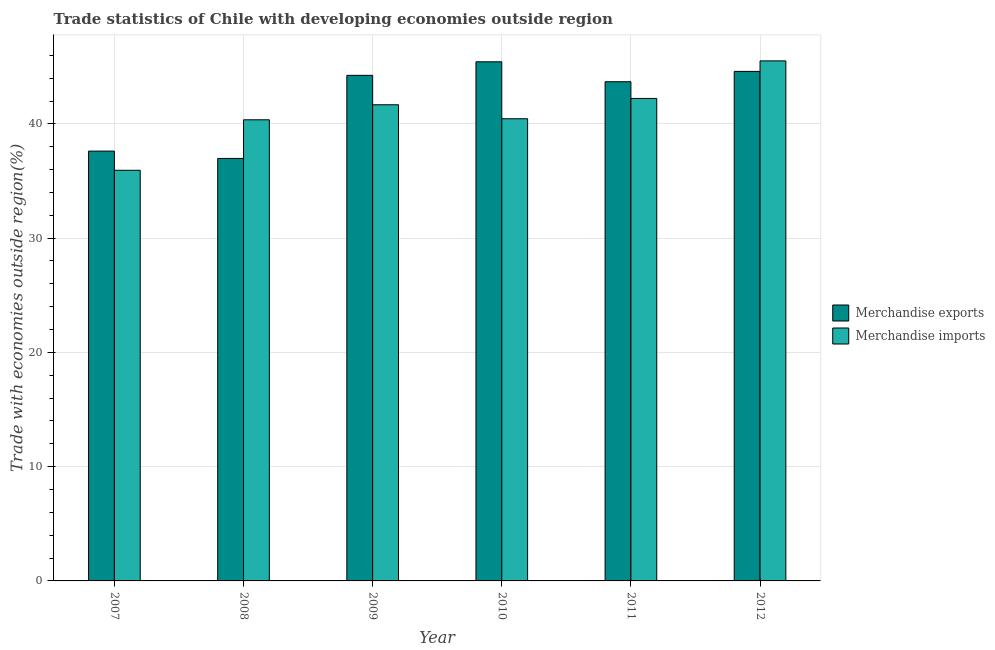Are the number of bars on each tick of the X-axis equal?
Provide a succinct answer. Yes. What is the label of the 1st group of bars from the left?
Ensure brevity in your answer.  2007. In how many cases, is the number of bars for a given year not equal to the number of legend labels?
Provide a succinct answer. 0. What is the merchandise exports in 2012?
Your answer should be compact. 44.59. Across all years, what is the maximum merchandise imports?
Your response must be concise. 45.51. Across all years, what is the minimum merchandise exports?
Keep it short and to the point. 36.98. In which year was the merchandise imports maximum?
Your response must be concise. 2012. In which year was the merchandise imports minimum?
Ensure brevity in your answer.  2007. What is the total merchandise exports in the graph?
Give a very brief answer. 252.56. What is the difference between the merchandise imports in 2007 and that in 2008?
Your response must be concise. -4.42. What is the difference between the merchandise exports in 2012 and the merchandise imports in 2009?
Your response must be concise. 0.35. What is the average merchandise imports per year?
Offer a very short reply. 41.03. What is the ratio of the merchandise imports in 2007 to that in 2008?
Provide a short and direct response. 0.89. What is the difference between the highest and the second highest merchandise imports?
Your response must be concise. 3.29. What is the difference between the highest and the lowest merchandise imports?
Offer a very short reply. 9.58. In how many years, is the merchandise imports greater than the average merchandise imports taken over all years?
Provide a short and direct response. 3. What does the 2nd bar from the left in 2011 represents?
Your answer should be compact. Merchandise imports. How many bars are there?
Your response must be concise. 12. What is the difference between two consecutive major ticks on the Y-axis?
Offer a very short reply. 10. Does the graph contain any zero values?
Keep it short and to the point. No. Where does the legend appear in the graph?
Offer a terse response. Center right. What is the title of the graph?
Offer a very short reply. Trade statistics of Chile with developing economies outside region. What is the label or title of the X-axis?
Your response must be concise. Year. What is the label or title of the Y-axis?
Give a very brief answer. Trade with economies outside region(%). What is the Trade with economies outside region(%) of Merchandise exports in 2007?
Ensure brevity in your answer.  37.62. What is the Trade with economies outside region(%) in Merchandise imports in 2007?
Offer a very short reply. 35.94. What is the Trade with economies outside region(%) of Merchandise exports in 2008?
Provide a short and direct response. 36.98. What is the Trade with economies outside region(%) in Merchandise imports in 2008?
Provide a short and direct response. 40.36. What is the Trade with economies outside region(%) in Merchandise exports in 2009?
Make the answer very short. 44.25. What is the Trade with economies outside region(%) of Merchandise imports in 2009?
Ensure brevity in your answer.  41.67. What is the Trade with economies outside region(%) of Merchandise exports in 2010?
Provide a short and direct response. 45.44. What is the Trade with economies outside region(%) in Merchandise imports in 2010?
Give a very brief answer. 40.45. What is the Trade with economies outside region(%) in Merchandise exports in 2011?
Your response must be concise. 43.69. What is the Trade with economies outside region(%) of Merchandise imports in 2011?
Your response must be concise. 42.23. What is the Trade with economies outside region(%) in Merchandise exports in 2012?
Provide a succinct answer. 44.59. What is the Trade with economies outside region(%) in Merchandise imports in 2012?
Give a very brief answer. 45.51. Across all years, what is the maximum Trade with economies outside region(%) of Merchandise exports?
Offer a terse response. 45.44. Across all years, what is the maximum Trade with economies outside region(%) of Merchandise imports?
Offer a terse response. 45.51. Across all years, what is the minimum Trade with economies outside region(%) of Merchandise exports?
Keep it short and to the point. 36.98. Across all years, what is the minimum Trade with economies outside region(%) in Merchandise imports?
Ensure brevity in your answer.  35.94. What is the total Trade with economies outside region(%) in Merchandise exports in the graph?
Offer a terse response. 252.56. What is the total Trade with economies outside region(%) in Merchandise imports in the graph?
Your answer should be compact. 246.17. What is the difference between the Trade with economies outside region(%) of Merchandise exports in 2007 and that in 2008?
Provide a short and direct response. 0.64. What is the difference between the Trade with economies outside region(%) of Merchandise imports in 2007 and that in 2008?
Offer a terse response. -4.42. What is the difference between the Trade with economies outside region(%) of Merchandise exports in 2007 and that in 2009?
Offer a terse response. -6.63. What is the difference between the Trade with economies outside region(%) in Merchandise imports in 2007 and that in 2009?
Ensure brevity in your answer.  -5.73. What is the difference between the Trade with economies outside region(%) of Merchandise exports in 2007 and that in 2010?
Offer a very short reply. -7.82. What is the difference between the Trade with economies outside region(%) in Merchandise imports in 2007 and that in 2010?
Offer a very short reply. -4.51. What is the difference between the Trade with economies outside region(%) of Merchandise exports in 2007 and that in 2011?
Your answer should be compact. -6.07. What is the difference between the Trade with economies outside region(%) of Merchandise imports in 2007 and that in 2011?
Give a very brief answer. -6.29. What is the difference between the Trade with economies outside region(%) of Merchandise exports in 2007 and that in 2012?
Provide a short and direct response. -6.98. What is the difference between the Trade with economies outside region(%) in Merchandise imports in 2007 and that in 2012?
Give a very brief answer. -9.58. What is the difference between the Trade with economies outside region(%) in Merchandise exports in 2008 and that in 2009?
Ensure brevity in your answer.  -7.27. What is the difference between the Trade with economies outside region(%) of Merchandise imports in 2008 and that in 2009?
Keep it short and to the point. -1.32. What is the difference between the Trade with economies outside region(%) in Merchandise exports in 2008 and that in 2010?
Offer a very short reply. -8.46. What is the difference between the Trade with economies outside region(%) in Merchandise imports in 2008 and that in 2010?
Your response must be concise. -0.09. What is the difference between the Trade with economies outside region(%) of Merchandise exports in 2008 and that in 2011?
Ensure brevity in your answer.  -6.71. What is the difference between the Trade with economies outside region(%) of Merchandise imports in 2008 and that in 2011?
Provide a succinct answer. -1.87. What is the difference between the Trade with economies outside region(%) in Merchandise exports in 2008 and that in 2012?
Provide a short and direct response. -7.62. What is the difference between the Trade with economies outside region(%) in Merchandise imports in 2008 and that in 2012?
Give a very brief answer. -5.16. What is the difference between the Trade with economies outside region(%) in Merchandise exports in 2009 and that in 2010?
Keep it short and to the point. -1.19. What is the difference between the Trade with economies outside region(%) in Merchandise imports in 2009 and that in 2010?
Keep it short and to the point. 1.22. What is the difference between the Trade with economies outside region(%) of Merchandise exports in 2009 and that in 2011?
Your answer should be very brief. 0.56. What is the difference between the Trade with economies outside region(%) in Merchandise imports in 2009 and that in 2011?
Provide a short and direct response. -0.56. What is the difference between the Trade with economies outside region(%) of Merchandise exports in 2009 and that in 2012?
Your answer should be very brief. -0.35. What is the difference between the Trade with economies outside region(%) in Merchandise imports in 2009 and that in 2012?
Provide a short and direct response. -3.84. What is the difference between the Trade with economies outside region(%) in Merchandise exports in 2010 and that in 2011?
Provide a short and direct response. 1.75. What is the difference between the Trade with economies outside region(%) in Merchandise imports in 2010 and that in 2011?
Give a very brief answer. -1.78. What is the difference between the Trade with economies outside region(%) in Merchandise exports in 2010 and that in 2012?
Your response must be concise. 0.84. What is the difference between the Trade with economies outside region(%) of Merchandise imports in 2010 and that in 2012?
Offer a terse response. -5.06. What is the difference between the Trade with economies outside region(%) in Merchandise exports in 2011 and that in 2012?
Your response must be concise. -0.9. What is the difference between the Trade with economies outside region(%) of Merchandise imports in 2011 and that in 2012?
Ensure brevity in your answer.  -3.29. What is the difference between the Trade with economies outside region(%) in Merchandise exports in 2007 and the Trade with economies outside region(%) in Merchandise imports in 2008?
Ensure brevity in your answer.  -2.74. What is the difference between the Trade with economies outside region(%) in Merchandise exports in 2007 and the Trade with economies outside region(%) in Merchandise imports in 2009?
Offer a very short reply. -4.06. What is the difference between the Trade with economies outside region(%) in Merchandise exports in 2007 and the Trade with economies outside region(%) in Merchandise imports in 2010?
Ensure brevity in your answer.  -2.83. What is the difference between the Trade with economies outside region(%) in Merchandise exports in 2007 and the Trade with economies outside region(%) in Merchandise imports in 2011?
Your answer should be compact. -4.61. What is the difference between the Trade with economies outside region(%) in Merchandise exports in 2007 and the Trade with economies outside region(%) in Merchandise imports in 2012?
Keep it short and to the point. -7.9. What is the difference between the Trade with economies outside region(%) of Merchandise exports in 2008 and the Trade with economies outside region(%) of Merchandise imports in 2009?
Ensure brevity in your answer.  -4.7. What is the difference between the Trade with economies outside region(%) of Merchandise exports in 2008 and the Trade with economies outside region(%) of Merchandise imports in 2010?
Make the answer very short. -3.47. What is the difference between the Trade with economies outside region(%) of Merchandise exports in 2008 and the Trade with economies outside region(%) of Merchandise imports in 2011?
Provide a short and direct response. -5.25. What is the difference between the Trade with economies outside region(%) in Merchandise exports in 2008 and the Trade with economies outside region(%) in Merchandise imports in 2012?
Provide a succinct answer. -8.54. What is the difference between the Trade with economies outside region(%) of Merchandise exports in 2009 and the Trade with economies outside region(%) of Merchandise imports in 2010?
Your answer should be very brief. 3.8. What is the difference between the Trade with economies outside region(%) of Merchandise exports in 2009 and the Trade with economies outside region(%) of Merchandise imports in 2011?
Make the answer very short. 2.02. What is the difference between the Trade with economies outside region(%) of Merchandise exports in 2009 and the Trade with economies outside region(%) of Merchandise imports in 2012?
Give a very brief answer. -1.27. What is the difference between the Trade with economies outside region(%) in Merchandise exports in 2010 and the Trade with economies outside region(%) in Merchandise imports in 2011?
Offer a terse response. 3.21. What is the difference between the Trade with economies outside region(%) in Merchandise exports in 2010 and the Trade with economies outside region(%) in Merchandise imports in 2012?
Offer a very short reply. -0.08. What is the difference between the Trade with economies outside region(%) of Merchandise exports in 2011 and the Trade with economies outside region(%) of Merchandise imports in 2012?
Give a very brief answer. -1.83. What is the average Trade with economies outside region(%) of Merchandise exports per year?
Your answer should be compact. 42.09. What is the average Trade with economies outside region(%) of Merchandise imports per year?
Offer a very short reply. 41.03. In the year 2007, what is the difference between the Trade with economies outside region(%) in Merchandise exports and Trade with economies outside region(%) in Merchandise imports?
Provide a succinct answer. 1.68. In the year 2008, what is the difference between the Trade with economies outside region(%) in Merchandise exports and Trade with economies outside region(%) in Merchandise imports?
Your answer should be very brief. -3.38. In the year 2009, what is the difference between the Trade with economies outside region(%) of Merchandise exports and Trade with economies outside region(%) of Merchandise imports?
Keep it short and to the point. 2.57. In the year 2010, what is the difference between the Trade with economies outside region(%) of Merchandise exports and Trade with economies outside region(%) of Merchandise imports?
Ensure brevity in your answer.  4.99. In the year 2011, what is the difference between the Trade with economies outside region(%) of Merchandise exports and Trade with economies outside region(%) of Merchandise imports?
Offer a terse response. 1.46. In the year 2012, what is the difference between the Trade with economies outside region(%) in Merchandise exports and Trade with economies outside region(%) in Merchandise imports?
Make the answer very short. -0.92. What is the ratio of the Trade with economies outside region(%) in Merchandise exports in 2007 to that in 2008?
Offer a very short reply. 1.02. What is the ratio of the Trade with economies outside region(%) of Merchandise imports in 2007 to that in 2008?
Provide a succinct answer. 0.89. What is the ratio of the Trade with economies outside region(%) of Merchandise exports in 2007 to that in 2009?
Your response must be concise. 0.85. What is the ratio of the Trade with economies outside region(%) in Merchandise imports in 2007 to that in 2009?
Your answer should be compact. 0.86. What is the ratio of the Trade with economies outside region(%) in Merchandise exports in 2007 to that in 2010?
Provide a succinct answer. 0.83. What is the ratio of the Trade with economies outside region(%) of Merchandise imports in 2007 to that in 2010?
Your answer should be compact. 0.89. What is the ratio of the Trade with economies outside region(%) of Merchandise exports in 2007 to that in 2011?
Your answer should be very brief. 0.86. What is the ratio of the Trade with economies outside region(%) in Merchandise imports in 2007 to that in 2011?
Offer a very short reply. 0.85. What is the ratio of the Trade with economies outside region(%) in Merchandise exports in 2007 to that in 2012?
Provide a short and direct response. 0.84. What is the ratio of the Trade with economies outside region(%) of Merchandise imports in 2007 to that in 2012?
Ensure brevity in your answer.  0.79. What is the ratio of the Trade with economies outside region(%) of Merchandise exports in 2008 to that in 2009?
Offer a terse response. 0.84. What is the ratio of the Trade with economies outside region(%) in Merchandise imports in 2008 to that in 2009?
Offer a very short reply. 0.97. What is the ratio of the Trade with economies outside region(%) of Merchandise exports in 2008 to that in 2010?
Your response must be concise. 0.81. What is the ratio of the Trade with economies outside region(%) in Merchandise exports in 2008 to that in 2011?
Your answer should be very brief. 0.85. What is the ratio of the Trade with economies outside region(%) of Merchandise imports in 2008 to that in 2011?
Offer a very short reply. 0.96. What is the ratio of the Trade with economies outside region(%) of Merchandise exports in 2008 to that in 2012?
Your answer should be very brief. 0.83. What is the ratio of the Trade with economies outside region(%) of Merchandise imports in 2008 to that in 2012?
Your answer should be very brief. 0.89. What is the ratio of the Trade with economies outside region(%) in Merchandise exports in 2009 to that in 2010?
Keep it short and to the point. 0.97. What is the ratio of the Trade with economies outside region(%) in Merchandise imports in 2009 to that in 2010?
Give a very brief answer. 1.03. What is the ratio of the Trade with economies outside region(%) of Merchandise exports in 2009 to that in 2011?
Offer a terse response. 1.01. What is the ratio of the Trade with economies outside region(%) of Merchandise imports in 2009 to that in 2011?
Offer a terse response. 0.99. What is the ratio of the Trade with economies outside region(%) of Merchandise imports in 2009 to that in 2012?
Provide a short and direct response. 0.92. What is the ratio of the Trade with economies outside region(%) of Merchandise exports in 2010 to that in 2011?
Ensure brevity in your answer.  1.04. What is the ratio of the Trade with economies outside region(%) of Merchandise imports in 2010 to that in 2011?
Your response must be concise. 0.96. What is the ratio of the Trade with economies outside region(%) of Merchandise exports in 2010 to that in 2012?
Give a very brief answer. 1.02. What is the ratio of the Trade with economies outside region(%) of Merchandise imports in 2010 to that in 2012?
Offer a very short reply. 0.89. What is the ratio of the Trade with economies outside region(%) in Merchandise exports in 2011 to that in 2012?
Keep it short and to the point. 0.98. What is the ratio of the Trade with economies outside region(%) in Merchandise imports in 2011 to that in 2012?
Provide a succinct answer. 0.93. What is the difference between the highest and the second highest Trade with economies outside region(%) in Merchandise exports?
Keep it short and to the point. 0.84. What is the difference between the highest and the second highest Trade with economies outside region(%) in Merchandise imports?
Offer a terse response. 3.29. What is the difference between the highest and the lowest Trade with economies outside region(%) of Merchandise exports?
Your answer should be compact. 8.46. What is the difference between the highest and the lowest Trade with economies outside region(%) of Merchandise imports?
Your answer should be compact. 9.58. 